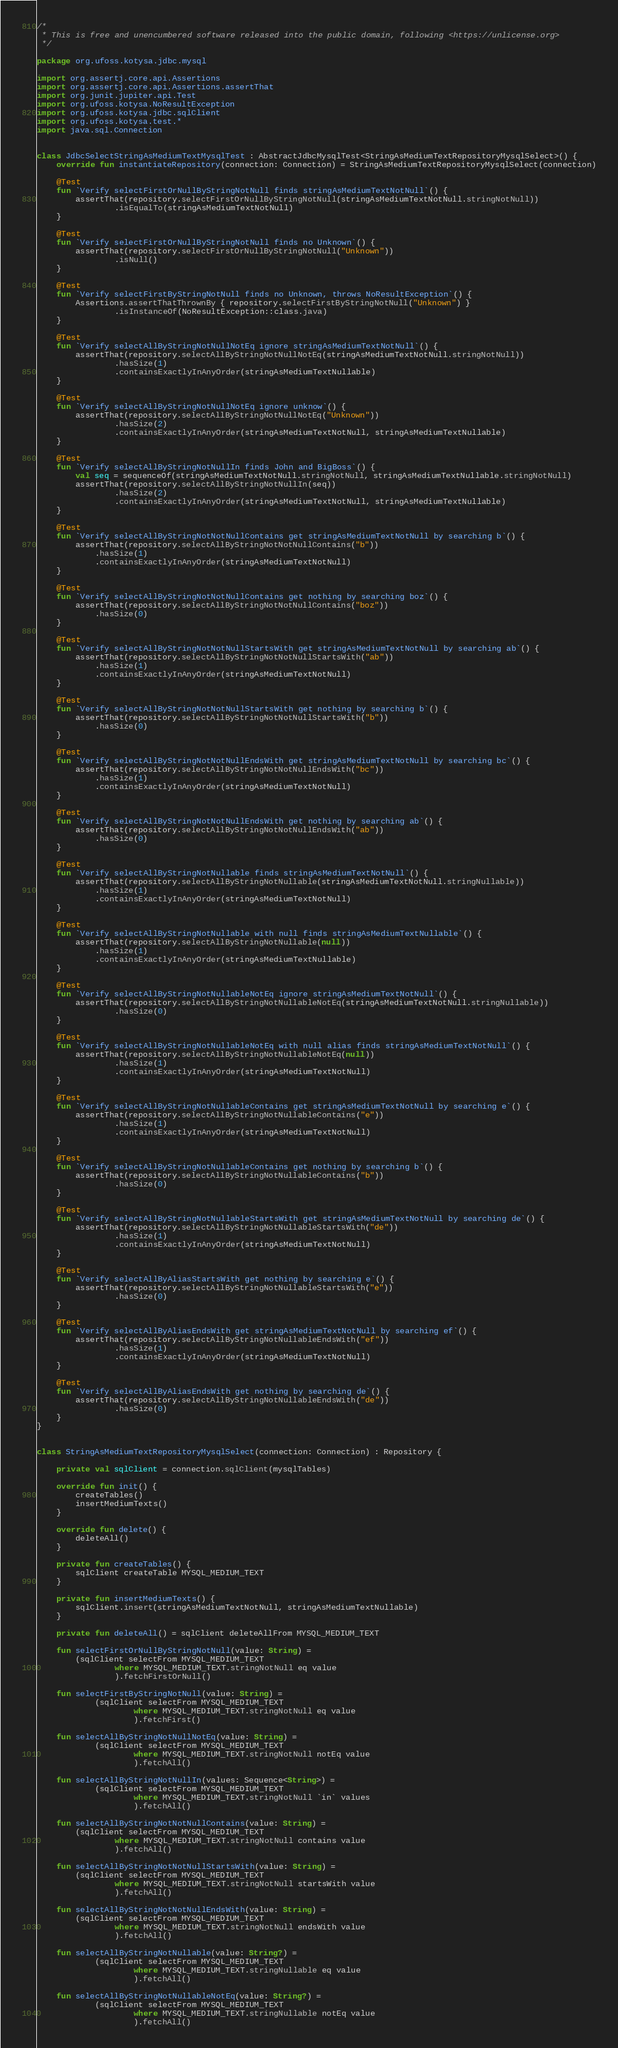Convert code to text. <code><loc_0><loc_0><loc_500><loc_500><_Kotlin_>/*
 * This is free and unencumbered software released into the public domain, following <https://unlicense.org>
 */

package org.ufoss.kotysa.jdbc.mysql

import org.assertj.core.api.Assertions
import org.assertj.core.api.Assertions.assertThat
import org.junit.jupiter.api.Test
import org.ufoss.kotysa.NoResultException
import org.ufoss.kotysa.jdbc.sqlClient
import org.ufoss.kotysa.test.*
import java.sql.Connection


class JdbcSelectStringAsMediumTextMysqlTest : AbstractJdbcMysqlTest<StringAsMediumTextRepositoryMysqlSelect>() {
    override fun instantiateRepository(connection: Connection) = StringAsMediumTextRepositoryMysqlSelect(connection)

    @Test
    fun `Verify selectFirstOrNullByStringNotNull finds stringAsMediumTextNotNull`() {
        assertThat(repository.selectFirstOrNullByStringNotNull(stringAsMediumTextNotNull.stringNotNull))
                .isEqualTo(stringAsMediumTextNotNull)
    }

    @Test
    fun `Verify selectFirstOrNullByStringNotNull finds no Unknown`() {
        assertThat(repository.selectFirstOrNullByStringNotNull("Unknown"))
                .isNull()
    }

    @Test
    fun `Verify selectFirstByStringNotNull finds no Unknown, throws NoResultException`() {
        Assertions.assertThatThrownBy { repository.selectFirstByStringNotNull("Unknown") }
                .isInstanceOf(NoResultException::class.java)
    }

    @Test
    fun `Verify selectAllByStringNotNullNotEq ignore stringAsMediumTextNotNull`() {
        assertThat(repository.selectAllByStringNotNullNotEq(stringAsMediumTextNotNull.stringNotNull))
                .hasSize(1)
                .containsExactlyInAnyOrder(stringAsMediumTextNullable)
    }

    @Test
    fun `Verify selectAllByStringNotNullNotEq ignore unknow`() {
        assertThat(repository.selectAllByStringNotNullNotEq("Unknown"))
                .hasSize(2)
                .containsExactlyInAnyOrder(stringAsMediumTextNotNull, stringAsMediumTextNullable)
    }

    @Test
    fun `Verify selectAllByStringNotNullIn finds John and BigBoss`() {
        val seq = sequenceOf(stringAsMediumTextNotNull.stringNotNull, stringAsMediumTextNullable.stringNotNull)
        assertThat(repository.selectAllByStringNotNullIn(seq))
                .hasSize(2)
                .containsExactlyInAnyOrder(stringAsMediumTextNotNull, stringAsMediumTextNullable)
    }

    @Test
    fun `Verify selectAllByStringNotNotNullContains get stringAsMediumTextNotNull by searching b`() {
        assertThat(repository.selectAllByStringNotNotNullContains("b"))
            .hasSize(1)
            .containsExactlyInAnyOrder(stringAsMediumTextNotNull)
    }

    @Test
    fun `Verify selectAllByStringNotNotNullContains get nothing by searching boz`() {
        assertThat(repository.selectAllByStringNotNotNullContains("boz"))
            .hasSize(0)
    }

    @Test
    fun `Verify selectAllByStringNotNotNullStartsWith get stringAsMediumTextNotNull by searching ab`() {
        assertThat(repository.selectAllByStringNotNotNullStartsWith("ab"))
            .hasSize(1)
            .containsExactlyInAnyOrder(stringAsMediumTextNotNull)
    }

    @Test
    fun `Verify selectAllByStringNotNotNullStartsWith get nothing by searching b`() {
        assertThat(repository.selectAllByStringNotNotNullStartsWith("b"))
            .hasSize(0)
    }

    @Test
    fun `Verify selectAllByStringNotNotNullEndsWith get stringAsMediumTextNotNull by searching bc`() {
        assertThat(repository.selectAllByStringNotNotNullEndsWith("bc"))
            .hasSize(1)
            .containsExactlyInAnyOrder(stringAsMediumTextNotNull)
    }

    @Test
    fun `Verify selectAllByStringNotNotNullEndsWith get nothing by searching ab`() {
        assertThat(repository.selectAllByStringNotNotNullEndsWith("ab"))
            .hasSize(0)
    }

    @Test
    fun `Verify selectAllByStringNotNullable finds stringAsMediumTextNotNull`() {
        assertThat(repository.selectAllByStringNotNullable(stringAsMediumTextNotNull.stringNullable))
            .hasSize(1)
            .containsExactlyInAnyOrder(stringAsMediumTextNotNull)
    }

    @Test
    fun `Verify selectAllByStringNotNullable with null finds stringAsMediumTextNullable`() {
        assertThat(repository.selectAllByStringNotNullable(null))
            .hasSize(1)
            .containsExactlyInAnyOrder(stringAsMediumTextNullable)
    }

    @Test
    fun `Verify selectAllByStringNotNullableNotEq ignore stringAsMediumTextNotNull`() {
        assertThat(repository.selectAllByStringNotNullableNotEq(stringAsMediumTextNotNull.stringNullable))
                .hasSize(0)
    }

    @Test
    fun `Verify selectAllByStringNotNullableNotEq with null alias finds stringAsMediumTextNotNull`() {
        assertThat(repository.selectAllByStringNotNullableNotEq(null))
                .hasSize(1)
                .containsExactlyInAnyOrder(stringAsMediumTextNotNull)
    }

    @Test
    fun `Verify selectAllByStringNotNullableContains get stringAsMediumTextNotNull by searching e`() {
        assertThat(repository.selectAllByStringNotNullableContains("e"))
                .hasSize(1)
                .containsExactlyInAnyOrder(stringAsMediumTextNotNull)
    }

    @Test
    fun `Verify selectAllByStringNotNullableContains get nothing by searching b`() {
        assertThat(repository.selectAllByStringNotNullableContains("b"))
                .hasSize(0)
    }

    @Test
    fun `Verify selectAllByStringNotNullableStartsWith get stringAsMediumTextNotNull by searching de`() {
        assertThat(repository.selectAllByStringNotNullableStartsWith("de"))
                .hasSize(1)
                .containsExactlyInAnyOrder(stringAsMediumTextNotNull)
    }

    @Test
    fun `Verify selectAllByAliasStartsWith get nothing by searching e`() {
        assertThat(repository.selectAllByStringNotNullableStartsWith("e"))
                .hasSize(0)
    }

    @Test
    fun `Verify selectAllByAliasEndsWith get stringAsMediumTextNotNull by searching ef`() {
        assertThat(repository.selectAllByStringNotNullableEndsWith("ef"))
                .hasSize(1)
                .containsExactlyInAnyOrder(stringAsMediumTextNotNull)
    }

    @Test
    fun `Verify selectAllByAliasEndsWith get nothing by searching de`() {
        assertThat(repository.selectAllByStringNotNullableEndsWith("de"))
                .hasSize(0)
    }
}


class StringAsMediumTextRepositoryMysqlSelect(connection: Connection) : Repository {

    private val sqlClient = connection.sqlClient(mysqlTables)

    override fun init() {
        createTables()
        insertMediumTexts()
    }

    override fun delete() {
        deleteAll()
    }

    private fun createTables() {
        sqlClient createTable MYSQL_MEDIUM_TEXT
    }

    private fun insertMediumTexts() {
        sqlClient.insert(stringAsMediumTextNotNull, stringAsMediumTextNullable)
    }

    private fun deleteAll() = sqlClient deleteAllFrom MYSQL_MEDIUM_TEXT

    fun selectFirstOrNullByStringNotNull(value: String) =
        (sqlClient selectFrom MYSQL_MEDIUM_TEXT
                where MYSQL_MEDIUM_TEXT.stringNotNull eq value
                ).fetchFirstOrNull()

    fun selectFirstByStringNotNull(value: String) =
            (sqlClient selectFrom MYSQL_MEDIUM_TEXT
                    where MYSQL_MEDIUM_TEXT.stringNotNull eq value
                    ).fetchFirst()

    fun selectAllByStringNotNullNotEq(value: String) =
            (sqlClient selectFrom MYSQL_MEDIUM_TEXT
                    where MYSQL_MEDIUM_TEXT.stringNotNull notEq value
                    ).fetchAll()

    fun selectAllByStringNotNullIn(values: Sequence<String>) =
            (sqlClient selectFrom MYSQL_MEDIUM_TEXT
                    where MYSQL_MEDIUM_TEXT.stringNotNull `in` values
                    ).fetchAll()

    fun selectAllByStringNotNotNullContains(value: String) =
        (sqlClient selectFrom MYSQL_MEDIUM_TEXT
                where MYSQL_MEDIUM_TEXT.stringNotNull contains value
                ).fetchAll()

    fun selectAllByStringNotNotNullStartsWith(value: String) =
        (sqlClient selectFrom MYSQL_MEDIUM_TEXT
                where MYSQL_MEDIUM_TEXT.stringNotNull startsWith value
                ).fetchAll()

    fun selectAllByStringNotNotNullEndsWith(value: String) =
        (sqlClient selectFrom MYSQL_MEDIUM_TEXT
                where MYSQL_MEDIUM_TEXT.stringNotNull endsWith value
                ).fetchAll()

    fun selectAllByStringNotNullable(value: String?) =
            (sqlClient selectFrom MYSQL_MEDIUM_TEXT
                    where MYSQL_MEDIUM_TEXT.stringNullable eq value
                    ).fetchAll()

    fun selectAllByStringNotNullableNotEq(value: String?) =
            (sqlClient selectFrom MYSQL_MEDIUM_TEXT
                    where MYSQL_MEDIUM_TEXT.stringNullable notEq value
                    ).fetchAll()
</code> 